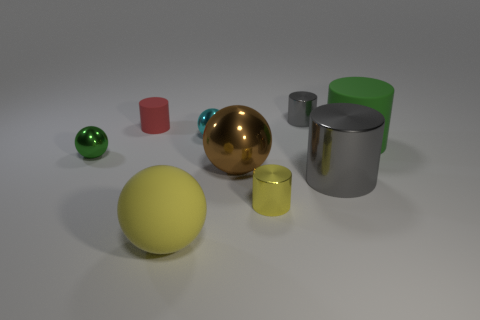What size is the thing that is the same color as the large matte cylinder?
Keep it short and to the point. Small. Does the small shiny cylinder that is behind the big brown metallic thing have the same color as the large metallic thing that is right of the small yellow cylinder?
Give a very brief answer. Yes. Are there more tiny yellow objects that are on the left side of the large green rubber thing than yellow things that are behind the large brown sphere?
Your response must be concise. Yes. What is the material of the brown thing?
Give a very brief answer. Metal. Are there any red things that have the same size as the cyan metallic sphere?
Give a very brief answer. Yes. What material is the gray object that is the same size as the yellow cylinder?
Your answer should be very brief. Metal. How many gray cylinders are there?
Ensure brevity in your answer.  2. There is a green thing on the left side of the big yellow ball; what is its size?
Keep it short and to the point. Small. Is the number of green shiny balls right of the green shiny object the same as the number of gray metallic spheres?
Provide a short and direct response. Yes. Are there any green objects of the same shape as the red matte object?
Make the answer very short. Yes. 